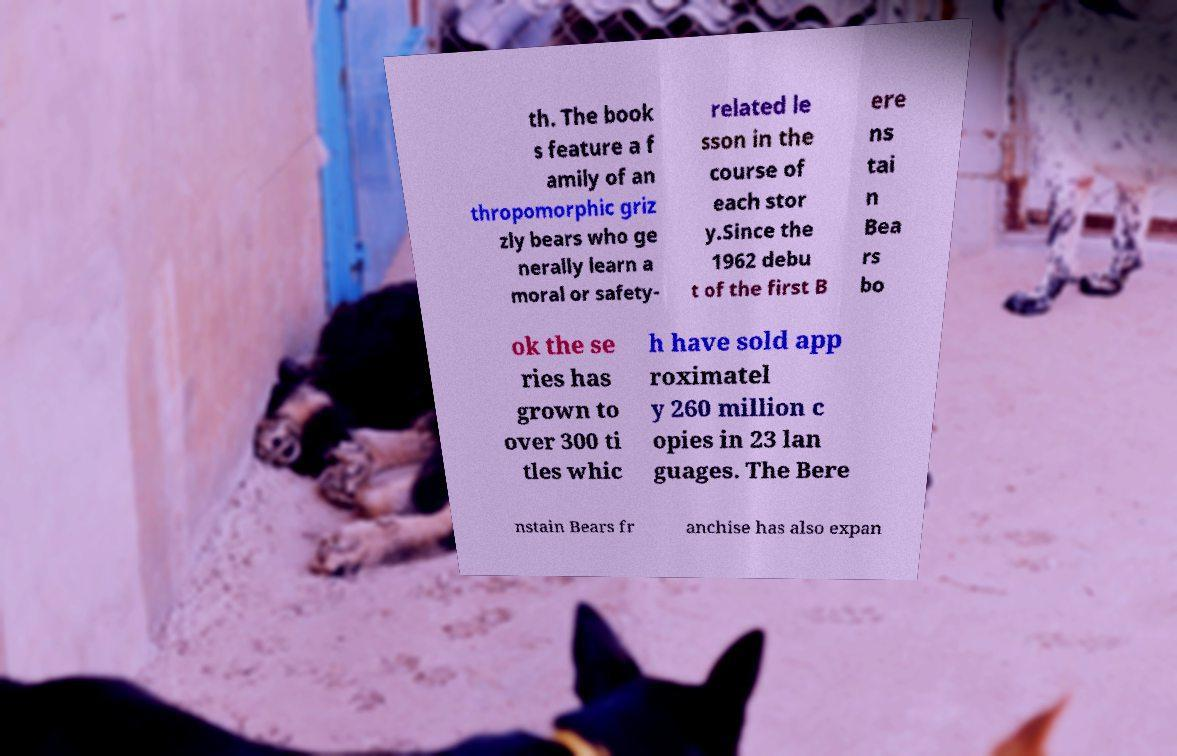Could you extract and type out the text from this image? th. The book s feature a f amily of an thropomorphic griz zly bears who ge nerally learn a moral or safety- related le sson in the course of each stor y.Since the 1962 debu t of the first B ere ns tai n Bea rs bo ok the se ries has grown to over 300 ti tles whic h have sold app roximatel y 260 million c opies in 23 lan guages. The Bere nstain Bears fr anchise has also expan 